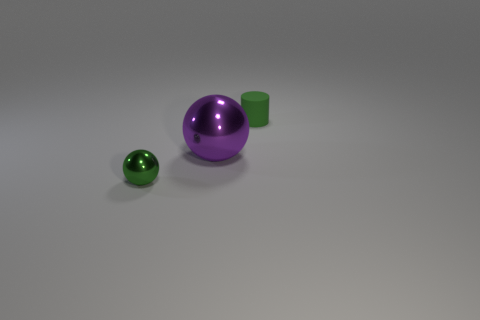Are there any other things that have the same size as the purple object?
Ensure brevity in your answer.  No. The other tiny object that is the same color as the tiny rubber object is what shape?
Give a very brief answer. Sphere. What is the material of the tiny green thing behind the purple ball?
Offer a terse response. Rubber. Does the green matte cylinder have the same size as the purple sphere?
Keep it short and to the point. No. Is the number of small objects that are right of the cylinder greater than the number of small shiny balls?
Give a very brief answer. No. What is the size of the thing that is made of the same material as the big purple ball?
Provide a short and direct response. Small. There is a rubber thing; are there any large metal spheres right of it?
Give a very brief answer. No. Is the shape of the big purple shiny object the same as the green matte object?
Keep it short and to the point. No. What size is the green object that is in front of the small object that is right of the tiny shiny thing that is in front of the small green matte object?
Your response must be concise. Small. What material is the green sphere?
Provide a succinct answer. Metal. 